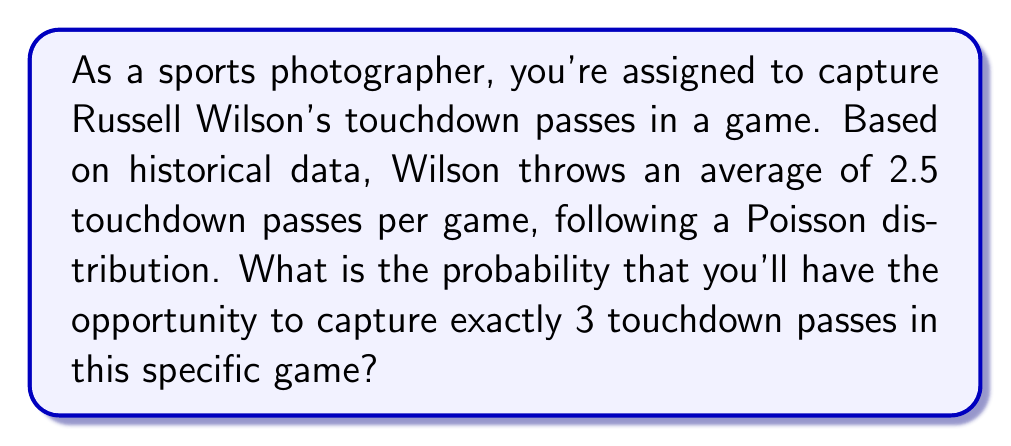Teach me how to tackle this problem. To solve this problem, we'll use the Poisson distribution formula:

$$P(X = k) = \frac{e^{-\lambda} \lambda^k}{k!}$$

Where:
$\lambda$ = average number of events (2.5 touchdown passes per game)
$k$ = number of events we're interested in (3 touchdown passes)
$e$ = Euler's number (approximately 2.71828)

Step 1: Plug in the values into the formula
$$P(X = 3) = \frac{e^{-2.5} 2.5^3}{3!}$$

Step 2: Calculate $e^{-2.5}$
$$e^{-2.5} \approx 0.0820$$

Step 3: Calculate $2.5^3$
$$2.5^3 = 15.625$$

Step 4: Calculate 3!
$$3! = 3 \times 2 \times 1 = 6$$

Step 5: Put it all together
$$P(X = 3) = \frac{0.0820 \times 15.625}{6} \approx 0.2138$$

Step 6: Convert to percentage
$$0.2138 \times 100\% = 21.38\%$$
Answer: 21.38% 